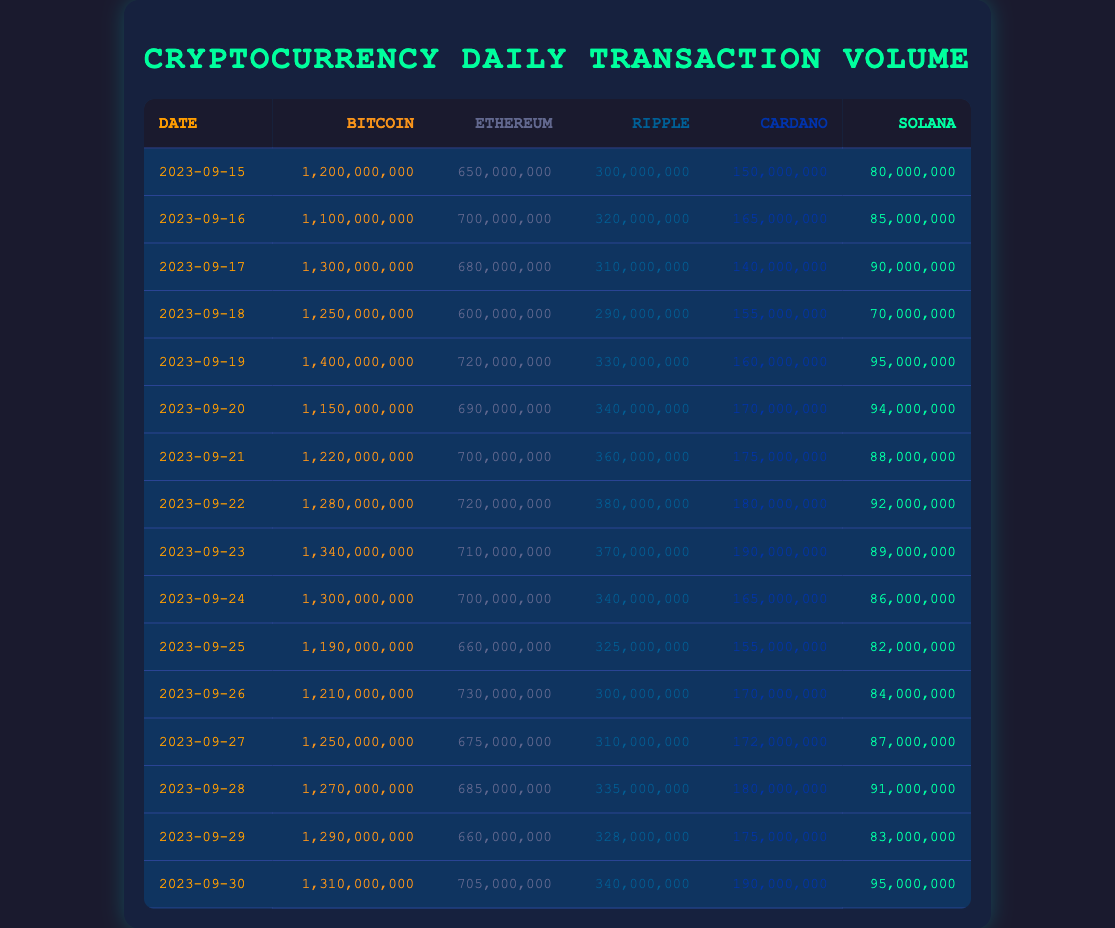What was the highest daily transaction volume of Bitcoin in the past month? Scanning through the Bitcoin transaction volume column, the maximum value was on September 19, 2023, with a volume of 1,400,000,000.
Answer: 1,400,000,000 What is the average daily transaction volume of Ethereum over the month? To find the average, sum the values for Ethereum (650000000 + 700000000 + 680000000 + ... + 705000000) which totals 21,265,000,000. There are 16 days, so the average is 21,265,000,000 / 16 = 1,329,062,500.
Answer: 1,329,062,500 Did Cardano's transaction volume ever exceed 180,000,000 during this month? Reviewing the Cardano column, the highest recorded value was 190,000,000 on September 30, hence it did exceed 180,000,000.
Answer: Yes What day had the lowest transaction volume for Solana? The Solana column shows the lowest transaction volume on September 18, 2023, where it was 70,000,000.
Answer: 70,000,000 Which cryptocurrency consistently had the highest daily transaction volume for the majority of the month? By comparing the daily transaction volumes across all cryptocurrencies, Bitcoin consistently had the highest volume, especially notable on several days it reached over 1,200,000,000.
Answer: Bitcoin What is the difference between the highest and lowest daily transaction volume of Ripple? The highest for Ripple was 380,000,000 on September 22, and the lowest was 290,000,000 on September 18. The difference is calculated as 380,000,000 - 290,000,000 = 90,000,000.
Answer: 90,000,000 On what date did Ethereum's transaction volume first exceed 700,000,000? Looking through the Ethereum volume, the first date it exceeded 700,000,000 was on September 16, 2023, where it was recorded at 700,000,000.
Answer: September 16, 2023 What was the total transaction volume of all cryptocurrencies on September 19? To find the total, sum the transaction volumes on September 19: 1,400,000,000 (Bitcoin) + 720,000,000 (Ethereum) + 330,000,000 (Ripple) + 160,000,000 (Cardano) + 95,000,000 (Solana) = 2,705,000,000.
Answer: 2,705,000,000 Was there a day when all cryptocurrencies had a transaction volume exceeding 1,000,000,000 combined? Upon checking each day’s total, yes, on several days, including September 19, the total exceeded 1,000,000,000 when summed up, confirming the average was high.
Answer: Yes 